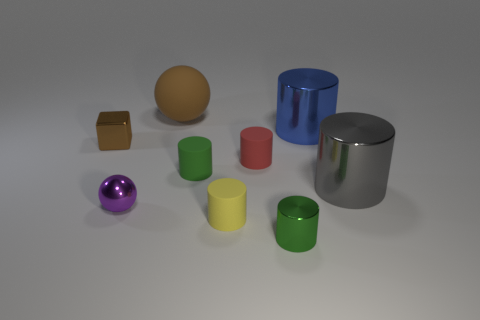Subtract all small metal cylinders. How many cylinders are left? 5 Subtract all red cylinders. How many cylinders are left? 5 Subtract all red cylinders. Subtract all purple blocks. How many cylinders are left? 5 Add 1 big blue shiny cylinders. How many objects exist? 10 Subtract all spheres. How many objects are left? 7 Subtract 1 blue cylinders. How many objects are left? 8 Subtract all tiny objects. Subtract all red rubber objects. How many objects are left? 2 Add 8 tiny green matte objects. How many tiny green matte objects are left? 9 Add 8 big cyan rubber balls. How many big cyan rubber balls exist? 8 